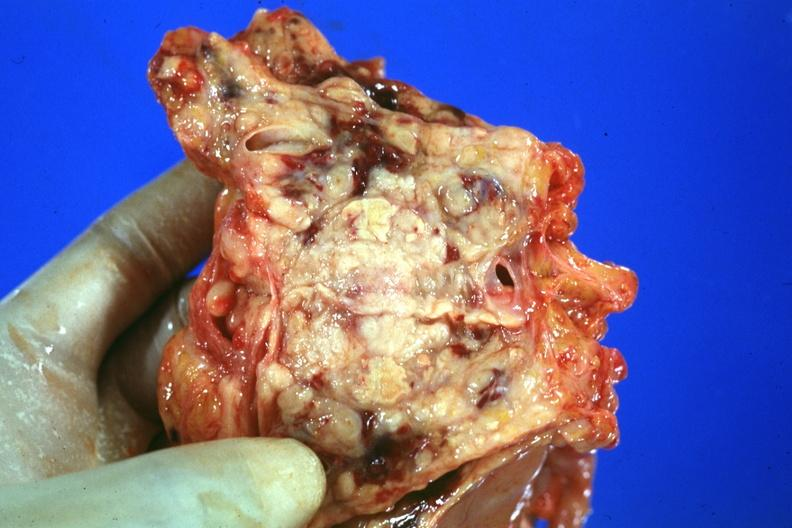does this image show prostate is cut open showing neoplasm quite good?
Answer the question using a single word or phrase. Yes 